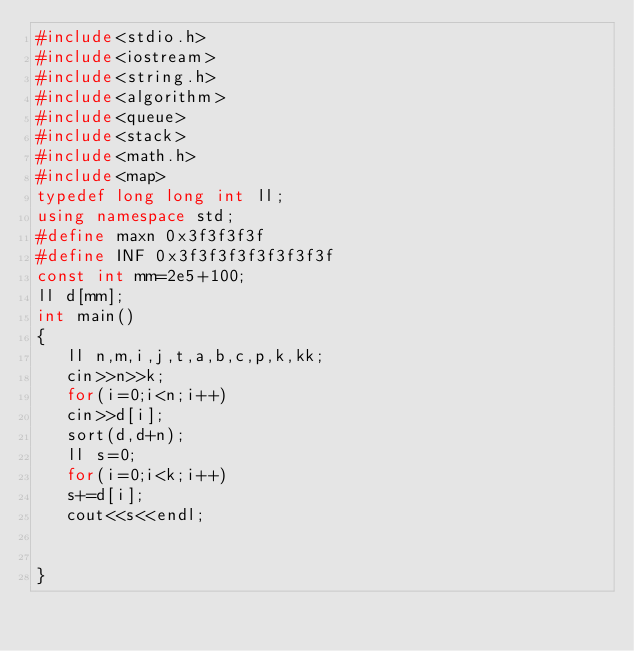<code> <loc_0><loc_0><loc_500><loc_500><_C++_>#include<stdio.h>
#include<iostream>
#include<string.h>
#include<algorithm>
#include<queue>
#include<stack>
#include<math.h>
#include<map>
typedef long long int ll;
using namespace std;
#define maxn 0x3f3f3f3f
#define INF 0x3f3f3f3f3f3f3f3f
const int mm=2e5+100;
ll d[mm];
int main()
{
   ll n,m,i,j,t,a,b,c,p,k,kk; 
   cin>>n>>k;
   for(i=0;i<n;i++)
   cin>>d[i];
   sort(d,d+n);
   ll s=0;
   for(i=0;i<k;i++)
   s+=d[i];
   cout<<s<<endl;
	  
	 
} </code> 